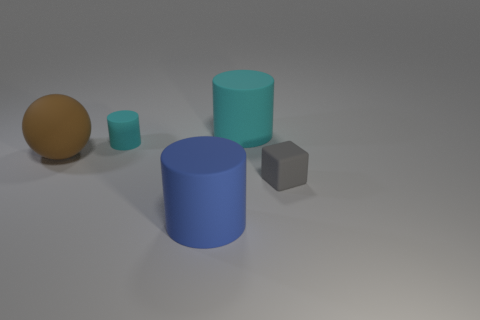Add 2 balls. How many objects exist? 7 Subtract all cylinders. How many objects are left? 2 Subtract all small gray objects. Subtract all big purple shiny blocks. How many objects are left? 4 Add 2 tiny gray cubes. How many tiny gray cubes are left? 3 Add 2 small cyan matte cylinders. How many small cyan matte cylinders exist? 3 Subtract 0 purple cylinders. How many objects are left? 5 